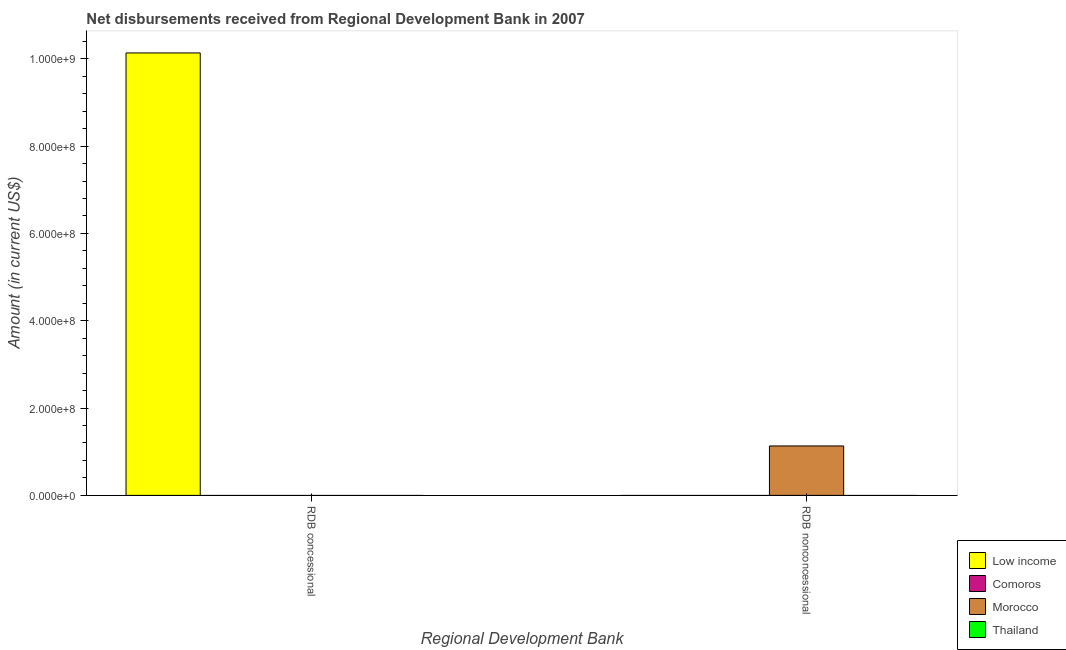Are the number of bars on each tick of the X-axis equal?
Ensure brevity in your answer.  Yes. How many bars are there on the 1st tick from the right?
Provide a succinct answer. 1. What is the label of the 1st group of bars from the left?
Provide a succinct answer. RDB concessional. What is the net concessional disbursements from rdb in Low income?
Your answer should be very brief. 1.01e+09. Across all countries, what is the maximum net non concessional disbursements from rdb?
Give a very brief answer. 1.13e+08. Across all countries, what is the minimum net concessional disbursements from rdb?
Offer a terse response. 0. In which country was the net non concessional disbursements from rdb maximum?
Provide a succinct answer. Morocco. What is the total net concessional disbursements from rdb in the graph?
Keep it short and to the point. 1.01e+09. What is the average net non concessional disbursements from rdb per country?
Offer a terse response. 2.83e+07. How many bars are there?
Make the answer very short. 2. How many countries are there in the graph?
Provide a short and direct response. 4. Does the graph contain any zero values?
Keep it short and to the point. Yes. How many legend labels are there?
Offer a terse response. 4. How are the legend labels stacked?
Give a very brief answer. Vertical. What is the title of the graph?
Give a very brief answer. Net disbursements received from Regional Development Bank in 2007. Does "Panama" appear as one of the legend labels in the graph?
Keep it short and to the point. No. What is the label or title of the X-axis?
Your response must be concise. Regional Development Bank. What is the label or title of the Y-axis?
Make the answer very short. Amount (in current US$). What is the Amount (in current US$) of Low income in RDB concessional?
Your answer should be very brief. 1.01e+09. What is the Amount (in current US$) in Low income in RDB nonconcessional?
Give a very brief answer. 0. What is the Amount (in current US$) of Morocco in RDB nonconcessional?
Make the answer very short. 1.13e+08. What is the Amount (in current US$) of Thailand in RDB nonconcessional?
Provide a short and direct response. 0. Across all Regional Development Bank, what is the maximum Amount (in current US$) in Low income?
Ensure brevity in your answer.  1.01e+09. Across all Regional Development Bank, what is the maximum Amount (in current US$) in Morocco?
Offer a terse response. 1.13e+08. Across all Regional Development Bank, what is the minimum Amount (in current US$) in Low income?
Keep it short and to the point. 0. Across all Regional Development Bank, what is the minimum Amount (in current US$) in Morocco?
Make the answer very short. 0. What is the total Amount (in current US$) in Low income in the graph?
Ensure brevity in your answer.  1.01e+09. What is the total Amount (in current US$) of Morocco in the graph?
Offer a very short reply. 1.13e+08. What is the difference between the Amount (in current US$) in Low income in RDB concessional and the Amount (in current US$) in Morocco in RDB nonconcessional?
Your answer should be compact. 9.00e+08. What is the average Amount (in current US$) in Low income per Regional Development Bank?
Make the answer very short. 5.07e+08. What is the average Amount (in current US$) in Morocco per Regional Development Bank?
Offer a very short reply. 5.66e+07. What is the average Amount (in current US$) of Thailand per Regional Development Bank?
Keep it short and to the point. 0. What is the difference between the highest and the lowest Amount (in current US$) in Low income?
Keep it short and to the point. 1.01e+09. What is the difference between the highest and the lowest Amount (in current US$) in Morocco?
Ensure brevity in your answer.  1.13e+08. 